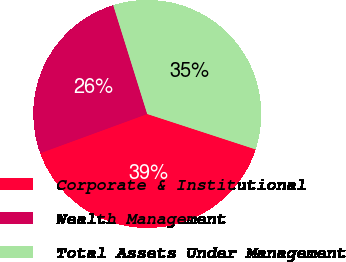<chart> <loc_0><loc_0><loc_500><loc_500><pie_chart><fcel>Corporate & Institutional<fcel>Wealth Management<fcel>Total Assets Under Management<nl><fcel>39.39%<fcel>25.76%<fcel>34.85%<nl></chart> 